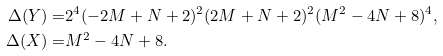Convert formula to latex. <formula><loc_0><loc_0><loc_500><loc_500>\Delta ( Y ) = & 2 ^ { 4 } ( - 2 M + N + 2 ) ^ { 2 } ( 2 M + N + 2 ) ^ { 2 } ( M ^ { 2 } - 4 N + 8 ) ^ { 4 } , \\ \Delta ( X ) = & M ^ { 2 } - 4 N + 8 .</formula> 